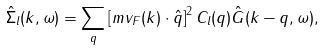Convert formula to latex. <formula><loc_0><loc_0><loc_500><loc_500>\hat { \Sigma } _ { l } ( { k } , \omega ) = \sum _ { q } \left [ m { v } _ { F } ( { k } ) \cdot \hat { q } \right ] ^ { 2 } C _ { l } ( { q } ) \hat { G } ( { k - q } , \omega ) ,</formula> 